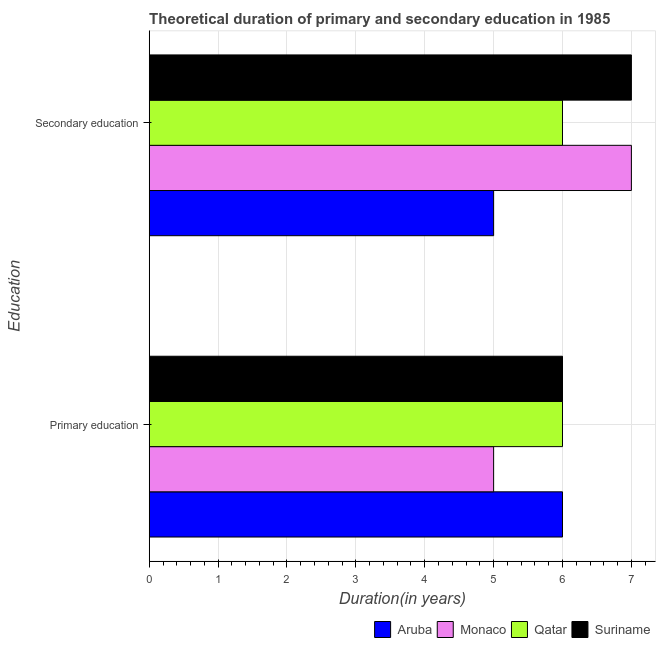How many different coloured bars are there?
Offer a very short reply. 4. How many groups of bars are there?
Ensure brevity in your answer.  2. Are the number of bars per tick equal to the number of legend labels?
Your answer should be compact. Yes. What is the duration of secondary education in Aruba?
Offer a terse response. 5. Across all countries, what is the minimum duration of secondary education?
Provide a short and direct response. 5. In which country was the duration of secondary education maximum?
Offer a terse response. Monaco. In which country was the duration of primary education minimum?
Ensure brevity in your answer.  Monaco. What is the total duration of primary education in the graph?
Your response must be concise. 23. What is the difference between the duration of primary education in Suriname and that in Monaco?
Keep it short and to the point. 1. What is the difference between the duration of primary education in Monaco and the duration of secondary education in Qatar?
Provide a succinct answer. -1. What is the average duration of secondary education per country?
Give a very brief answer. 6.25. What is the difference between the duration of primary education and duration of secondary education in Monaco?
Your answer should be very brief. -2. In how many countries, is the duration of secondary education greater than 1.4 years?
Give a very brief answer. 4. Is the duration of primary education in Monaco less than that in Aruba?
Offer a terse response. Yes. In how many countries, is the duration of secondary education greater than the average duration of secondary education taken over all countries?
Your answer should be very brief. 2. What does the 2nd bar from the top in Primary education represents?
Ensure brevity in your answer.  Qatar. What does the 4th bar from the bottom in Primary education represents?
Give a very brief answer. Suriname. What is the title of the graph?
Offer a terse response. Theoretical duration of primary and secondary education in 1985. Does "Dominican Republic" appear as one of the legend labels in the graph?
Offer a very short reply. No. What is the label or title of the X-axis?
Offer a very short reply. Duration(in years). What is the label or title of the Y-axis?
Offer a very short reply. Education. What is the Duration(in years) of Monaco in Primary education?
Keep it short and to the point. 5. What is the Duration(in years) of Suriname in Primary education?
Provide a short and direct response. 6. What is the Duration(in years) in Aruba in Secondary education?
Your response must be concise. 5. What is the Duration(in years) of Monaco in Secondary education?
Provide a short and direct response. 7. What is the Duration(in years) in Qatar in Secondary education?
Offer a very short reply. 6. Across all Education, what is the maximum Duration(in years) of Qatar?
Make the answer very short. 6. Across all Education, what is the minimum Duration(in years) in Aruba?
Make the answer very short. 5. Across all Education, what is the minimum Duration(in years) in Monaco?
Offer a terse response. 5. Across all Education, what is the minimum Duration(in years) in Qatar?
Your answer should be compact. 6. What is the total Duration(in years) of Aruba in the graph?
Keep it short and to the point. 11. What is the difference between the Duration(in years) in Monaco in Primary education and that in Secondary education?
Your answer should be very brief. -2. What is the difference between the Duration(in years) of Qatar in Primary education and that in Secondary education?
Your response must be concise. 0. What is the difference between the Duration(in years) in Aruba in Primary education and the Duration(in years) in Monaco in Secondary education?
Provide a short and direct response. -1. What is the difference between the Duration(in years) in Aruba in Primary education and the Duration(in years) in Suriname in Secondary education?
Give a very brief answer. -1. What is the difference between the Duration(in years) of Monaco in Primary education and the Duration(in years) of Suriname in Secondary education?
Ensure brevity in your answer.  -2. What is the difference between the Duration(in years) of Qatar in Primary education and the Duration(in years) of Suriname in Secondary education?
Your response must be concise. -1. What is the difference between the Duration(in years) in Aruba and Duration(in years) in Qatar in Primary education?
Offer a terse response. 0. What is the difference between the Duration(in years) of Monaco and Duration(in years) of Qatar in Primary education?
Your answer should be compact. -1. What is the difference between the Duration(in years) of Qatar and Duration(in years) of Suriname in Primary education?
Give a very brief answer. 0. What is the difference between the Duration(in years) of Aruba and Duration(in years) of Monaco in Secondary education?
Your answer should be compact. -2. What is the difference between the Duration(in years) of Monaco and Duration(in years) of Suriname in Secondary education?
Make the answer very short. 0. What is the ratio of the Duration(in years) in Qatar in Primary education to that in Secondary education?
Keep it short and to the point. 1. What is the difference between the highest and the second highest Duration(in years) of Qatar?
Provide a succinct answer. 0. What is the difference between the highest and the lowest Duration(in years) in Aruba?
Give a very brief answer. 1. What is the difference between the highest and the lowest Duration(in years) of Monaco?
Offer a terse response. 2. What is the difference between the highest and the lowest Duration(in years) in Qatar?
Your answer should be very brief. 0. 